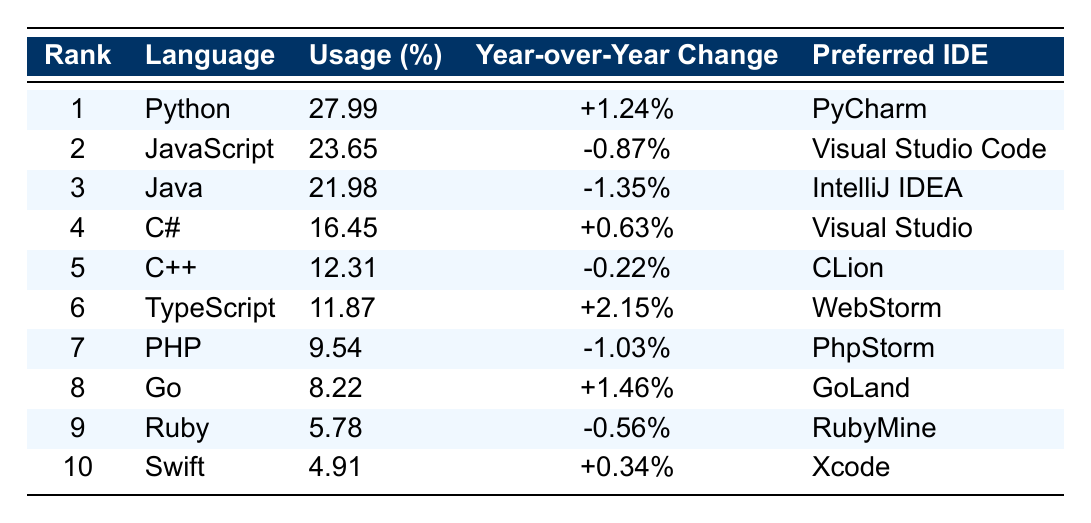What is the most popular programming language in 2023? The table shows that Python is ranked 1, indicating it is the most popular programming language in 2023.
Answer: Python Which programming language has the highest year-over-year change? Looking at the "Year-over-Year Change" column, TypeScript shows a change of +2.15%, which is the highest among all listed languages.
Answer: TypeScript How much is the usage percentage of C#? The "Usage (%)" for C# in the table is directly listed as 16.45%.
Answer: 16.45% Is the year-over-year change for Java positive or negative? The year-over-year change for Java is shown as -1.35% in the table, indicating a negative change.
Answer: Negative What is the average usage percentage of the top three programming languages? The usage percentages of the top three languages are 27.99% (Python), 23.65% (JavaScript), and 21.98% (Java). Their sum is 73.62%, and the average is 73.62% / 3 = 24.54%.
Answer: 24.54% Which programming language has a preferred IDE of GoLand? The table indicates that Go is the programming language with GoLand as its preferred IDE.
Answer: Go Is there a language in the table that has both a positive year-over-year change and a usage percentage above 10%? Yes, TypeScript has a year-over-year change of +2.15% and a usage percentage of 11.87%, satisfying both conditions.
Answer: Yes What is the difference in usage percentage between JavaScript and PHP? JavaScript has a usage of 23.65% and PHP has 9.54%. The difference is 23.65% - 9.54% = 14.11%.
Answer: 14.11% Which language is ranked 6th and what is its preferred IDE? The language ranked 6th is TypeScript and its preferred IDE is WebStorm, as shown in the table.
Answer: TypeScript, WebStorm How many languages in the list have a usage percentage less than 10%? The table indicates that PHP (9.54%), Go (8.22%), Ruby (5.78%), and Swift (4.91%) have a usage percentage less than 10%. This totals to four languages.
Answer: 4 